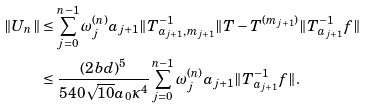<formula> <loc_0><loc_0><loc_500><loc_500>\| U _ { n } \| & \leq \sum _ { j = 0 } ^ { n - 1 } \omega _ { j } ^ { ( n ) } a _ { j + 1 } \| T _ { a _ { j + 1 } , m _ { j + 1 } } ^ { - 1 } \| T - T ^ { ( m _ { j + 1 } ) } \| T _ { a _ { j + 1 } } ^ { - 1 } f \| \\ & \leq \frac { ( 2 b d ) ^ { 5 } } { 5 4 0 \sqrt { 1 0 } a _ { 0 } \kappa ^ { 4 } } \sum _ { j = 0 } ^ { n - 1 } \omega _ { j } ^ { ( n ) } a _ { j + 1 } \| T _ { a _ { j + 1 } } ^ { - 1 } f \| .</formula> 